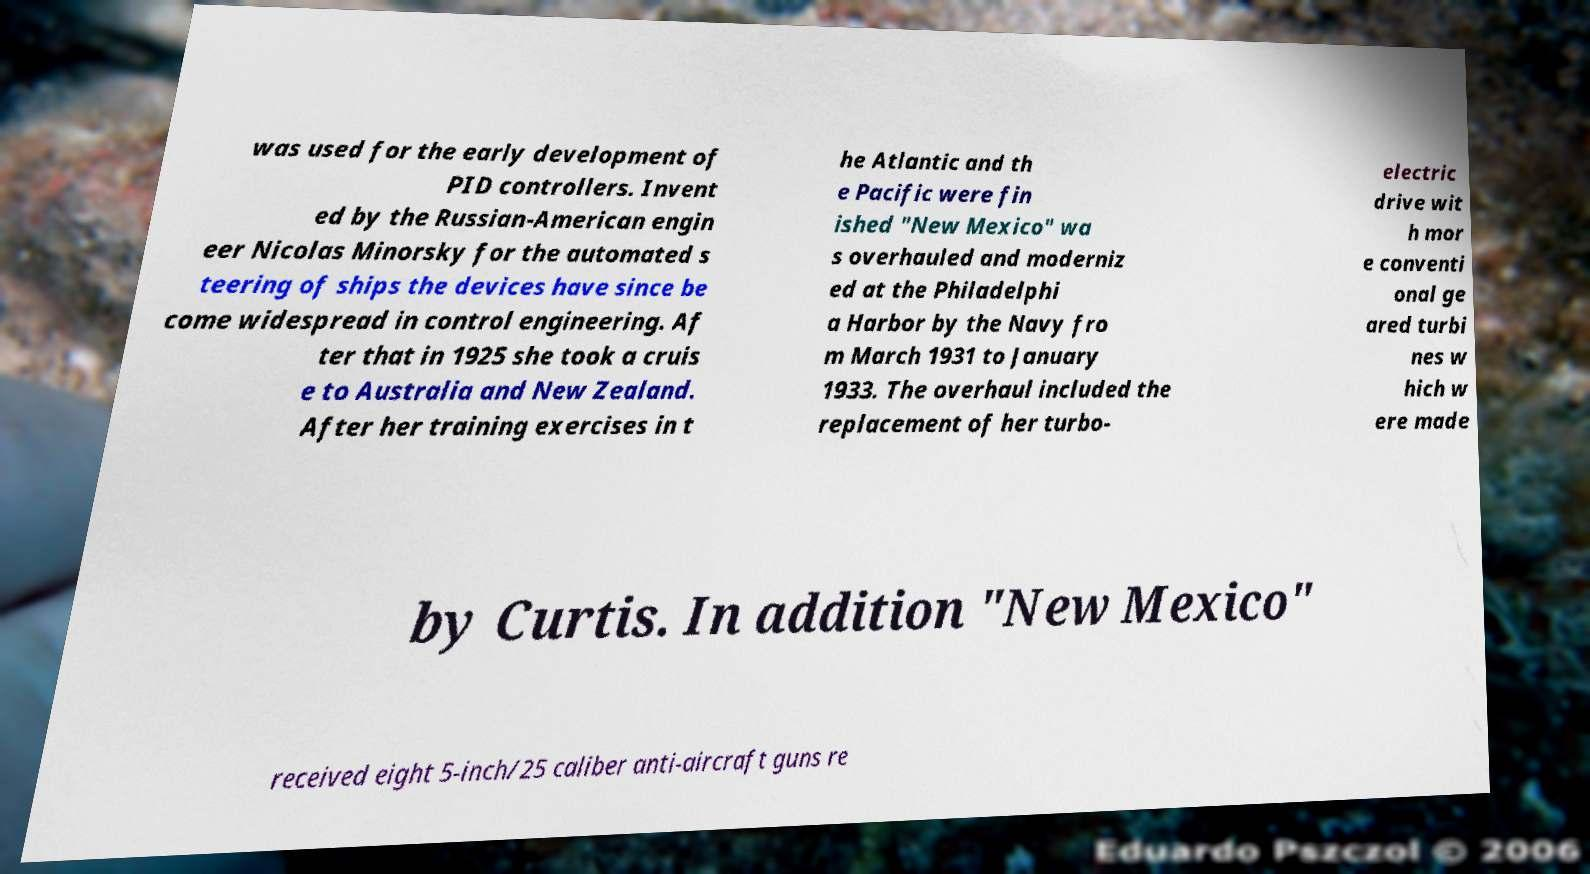Can you accurately transcribe the text from the provided image for me? was used for the early development of PID controllers. Invent ed by the Russian-American engin eer Nicolas Minorsky for the automated s teering of ships the devices have since be come widespread in control engineering. Af ter that in 1925 she took a cruis e to Australia and New Zealand. After her training exercises in t he Atlantic and th e Pacific were fin ished "New Mexico" wa s overhauled and moderniz ed at the Philadelphi a Harbor by the Navy fro m March 1931 to January 1933. The overhaul included the replacement of her turbo- electric drive wit h mor e conventi onal ge ared turbi nes w hich w ere made by Curtis. In addition "New Mexico" received eight 5-inch/25 caliber anti-aircraft guns re 